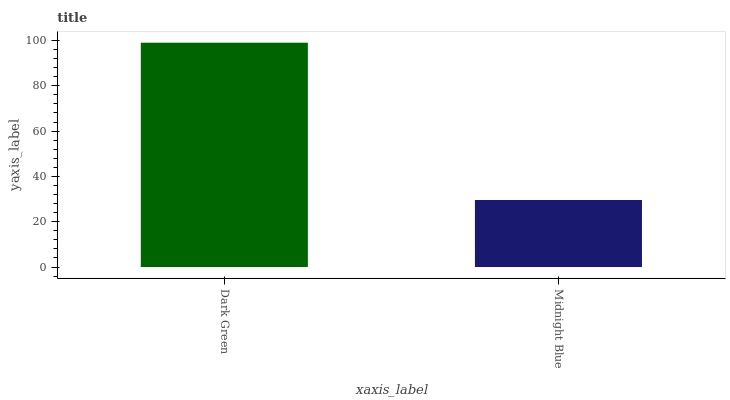Is Midnight Blue the minimum?
Answer yes or no. Yes. Is Dark Green the maximum?
Answer yes or no. Yes. Is Midnight Blue the maximum?
Answer yes or no. No. Is Dark Green greater than Midnight Blue?
Answer yes or no. Yes. Is Midnight Blue less than Dark Green?
Answer yes or no. Yes. Is Midnight Blue greater than Dark Green?
Answer yes or no. No. Is Dark Green less than Midnight Blue?
Answer yes or no. No. Is Dark Green the high median?
Answer yes or no. Yes. Is Midnight Blue the low median?
Answer yes or no. Yes. Is Midnight Blue the high median?
Answer yes or no. No. Is Dark Green the low median?
Answer yes or no. No. 